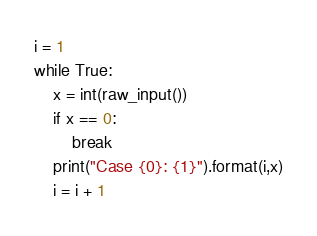Convert code to text. <code><loc_0><loc_0><loc_500><loc_500><_Python_>i = 1
while True:
    x = int(raw_input())
    if x == 0:
        break
    print("Case {0}: {1}").format(i,x)
    i = i + 1</code> 